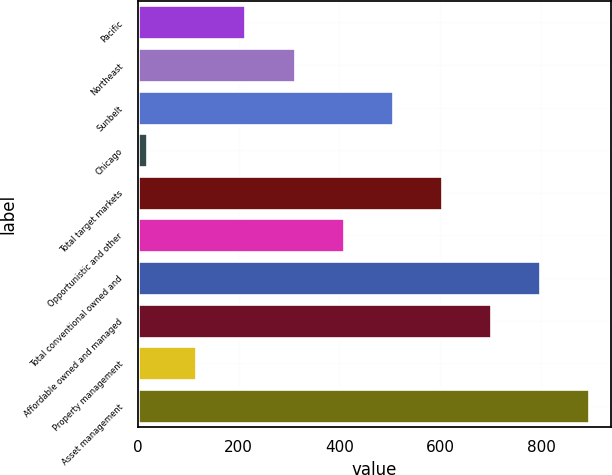<chart> <loc_0><loc_0><loc_500><loc_500><bar_chart><fcel>Pacific<fcel>Northeast<fcel>Sunbelt<fcel>Chicago<fcel>Total target markets<fcel>Opportunistic and other<fcel>Total conventional owned and<fcel>Affordable owned and managed<fcel>Property management<fcel>Asset management<nl><fcel>213.6<fcel>310.9<fcel>505.5<fcel>19<fcel>602.8<fcel>408.2<fcel>797.4<fcel>700.1<fcel>116.3<fcel>894.7<nl></chart> 